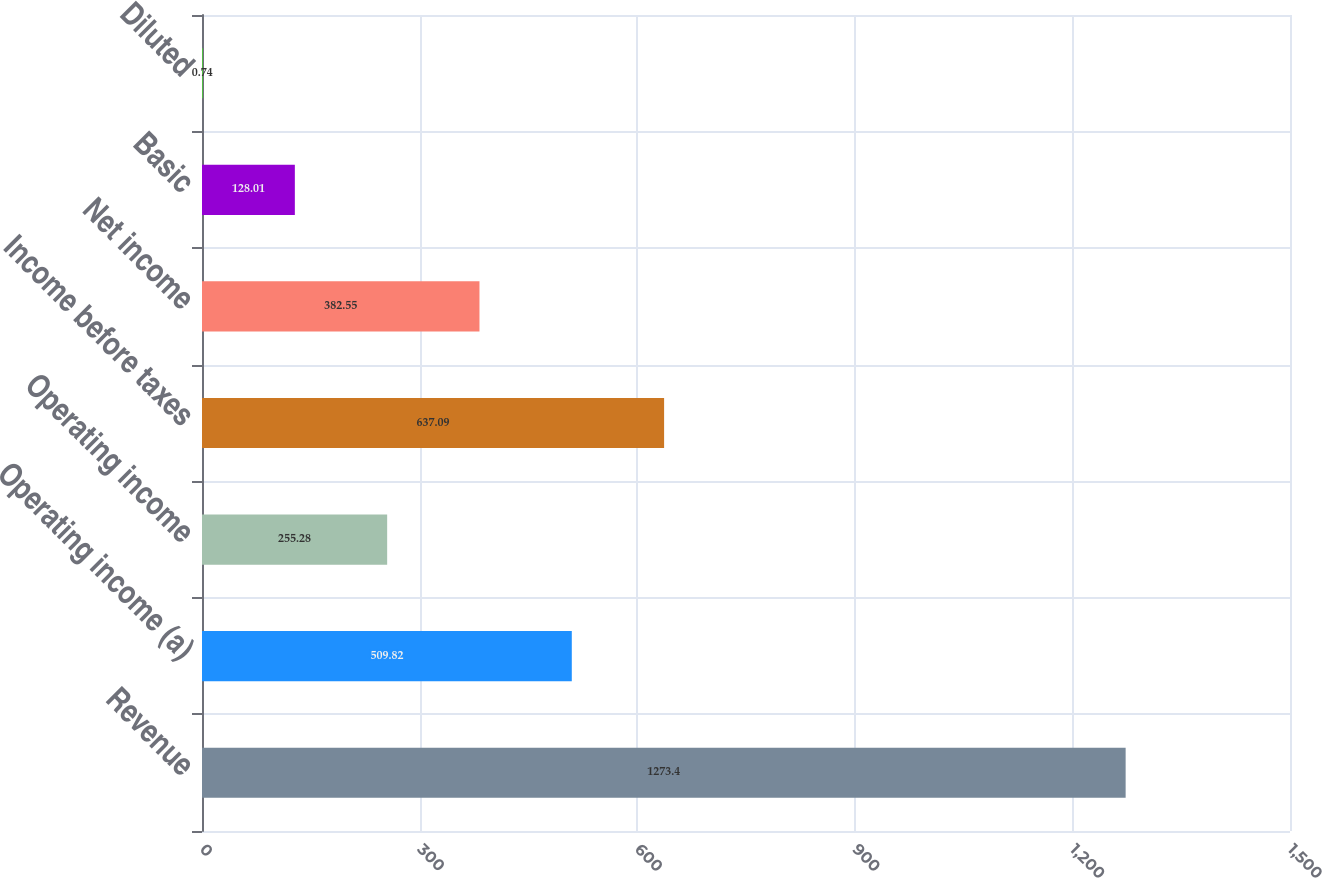<chart> <loc_0><loc_0><loc_500><loc_500><bar_chart><fcel>Revenue<fcel>Operating income (a)<fcel>Operating income<fcel>Income before taxes<fcel>Net income<fcel>Basic<fcel>Diluted<nl><fcel>1273.4<fcel>509.82<fcel>255.28<fcel>637.09<fcel>382.55<fcel>128.01<fcel>0.74<nl></chart> 